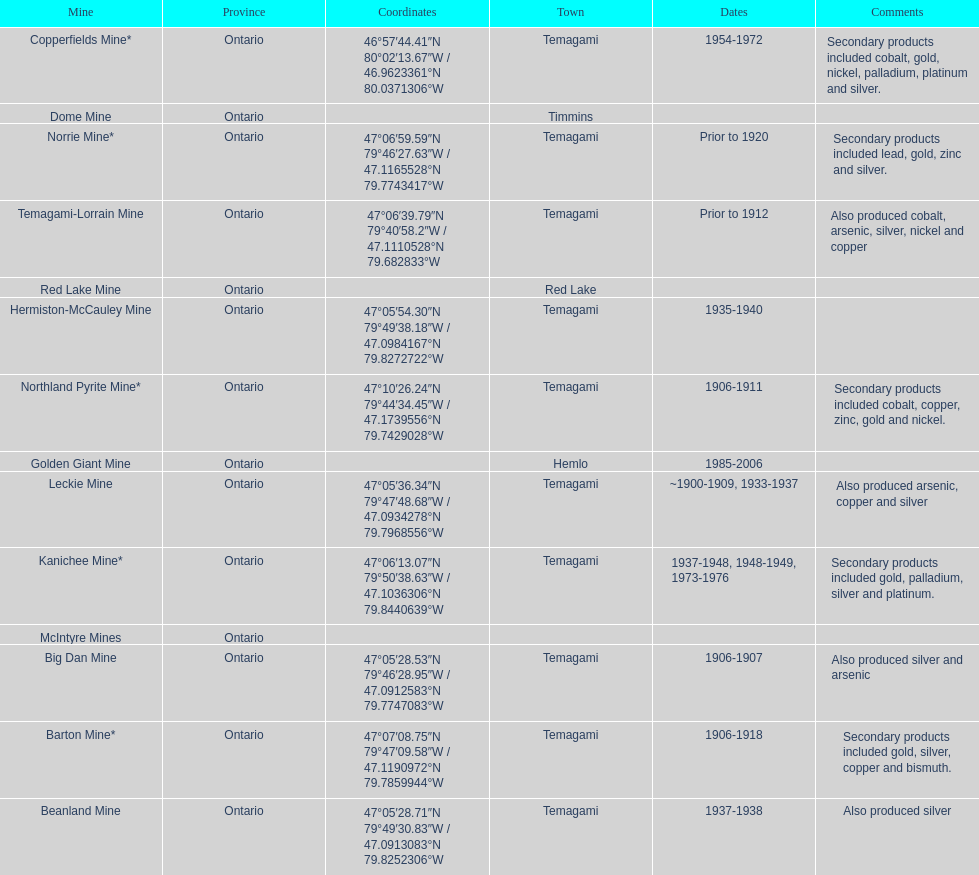What years was the golden giant mine open for? 1985-2006. What years was the beanland mine open? 1937-1938. Which of these two mines was open longer? Golden Giant Mine. 